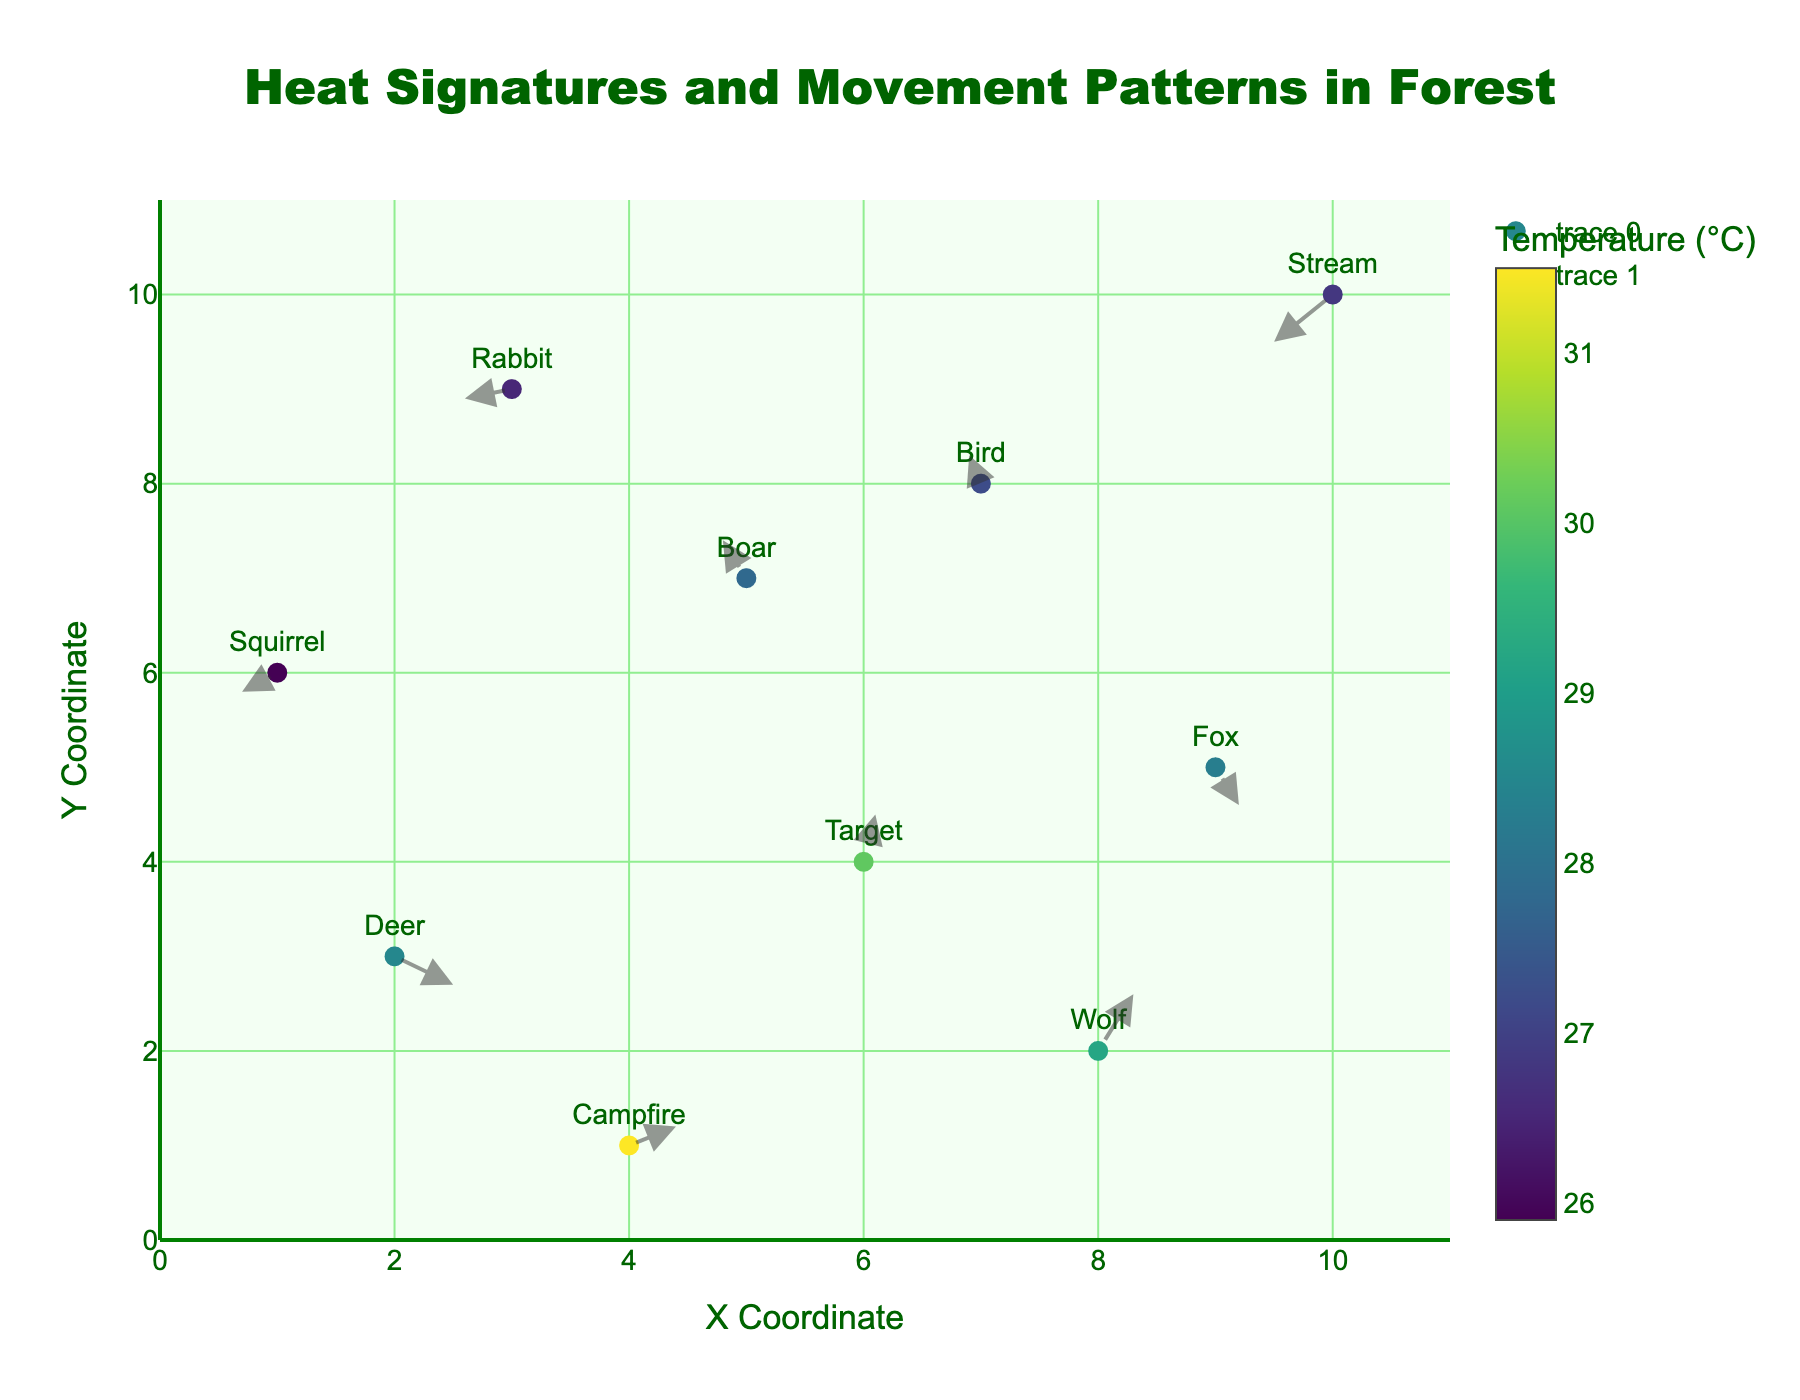what is the title of the plot? The title is shown at the top center of the figure. It reads "Heat Signatures and Movement Patterns in Forest"
Answer: Heat Signatures and Movement Patterns in Forest What is the color representing the highest temperature in the plot? The plot uses a Viridis color scale for temperatures. The highest temperature (31.5°C) is represented by a bright yellow color. Visual inspection of the colorbar confirms this.
Answer: Bright yellow How many entities are there in the plot? By counting the number of data points, each labeled with an entity, there are 10 unique labels. This value can be cross-verified with the data provided.
Answer: 10 What temperature is associated with the 'Target'? By referring to the figure and looking for the label "Target," we see that its associated temperature, as mentioned in the hover text, is 30.1°C.
Answer: 30.1°C Which entity has the lowest temperature, and what is it? By checking the temperatures in the hover text of each point, the "Squirrel" has the lowest temperature of 25.9°C.
Answer: Squirrel, 25.9°C In which quadrant is the 'Bird' located? The 'Bird' is at coordinates (7,8). Since both x and y are positive, it resides in the first quadrant.
Answer: First quadrant Compare the movements of 'Deer' and 'Rabbit'. Which direction do they move towards? By looking at their vectors:
- 'Deer' at (2, 3) moves with components (0.5, -0.3), indicating a direction towards the positive x-axis and negative y-axis.
- 'Rabbit' at (3, 9) moves with components (-0.4, -0.1), indicating a direction towards negative x and slightly negative y axis.
Thus, 'Deer' moves southeast while 'Rabbit' moves southwest.
Answer: Deer: Southeast, Rabbit: Southwest What is the average temperature of entities located in the first quadrant? From the plot, the first quadrant contains 'Bird' (27.2°C), 'Wolf' (29.2°C). Their average temperature is (27.2 + 29.2) / 2 = 28.2°C.
Answer: 28.2°C How far is the 'Campfire' from its original position after movement? The 'Campfire' at (4,1) moves with components (0.4, 0.2). The distance is calculated using the Pythagorean theorem: sqrt(0.4^2 + 0.2^2) = sqrt(0.16 + 0.04) = sqrt(0.2) = 0.45.
Answer: 0.45 units Which entity has the largest distance of movement and how far? Calculating the distance for each entity:
- Deer: sqrt(0.5^2 + 0.3^2) = 0.58
- Boar: sqrt(0.2^2 + 0.4^2) = 0.45
- Wolf: sqrt(0.3^2 + 0.6^2) = 0.67
- Rabbit: sqrt(0.4^2 + 0.1^2) = 0.41
- Target: sqrt(0.1^2 + 0.5^2) = 0.51
- Squirrel: sqrt(0.3^2 + 0.2^2) = 0.36
- Fox: sqrt(0.2^2 + 0.4^2) = 0.45
- Campfire: sqrt(0.4^2 + 0.2^2) = 0.45
- Bird: sqrt(0.1^2 + 0.3^2) = 0.32
- Stream: sqrt(0.5^2 + 0.5^2) = 0.71
The 'Stream' with a distance of 0.71 units has the largest movement.
Answer: Stream, 0.71 units 